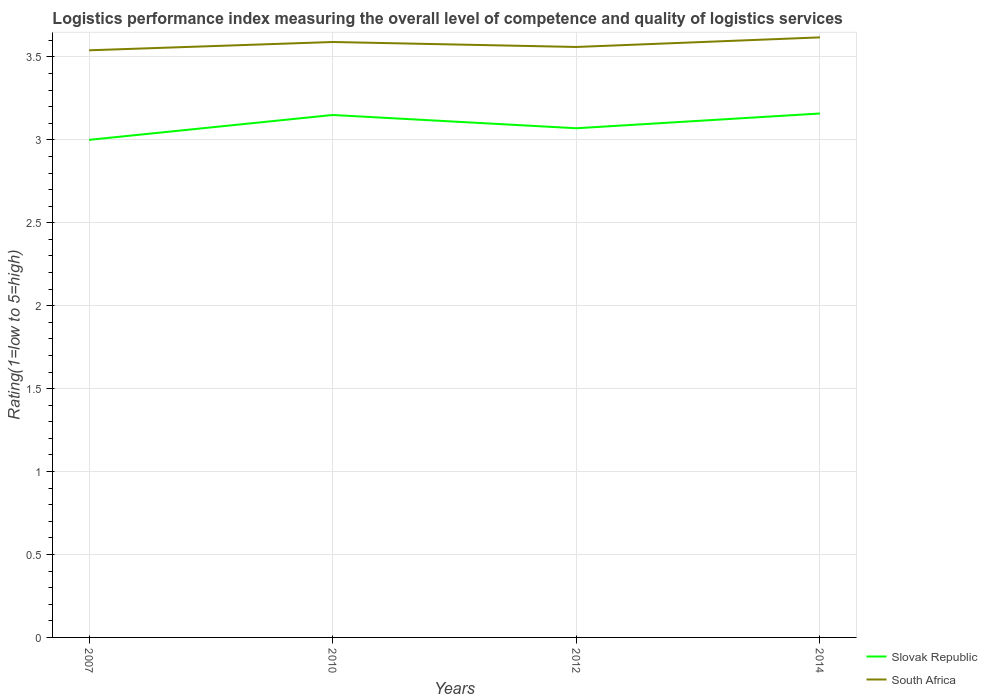How many different coloured lines are there?
Offer a terse response. 2. Does the line corresponding to South Africa intersect with the line corresponding to Slovak Republic?
Ensure brevity in your answer.  No. Is the number of lines equal to the number of legend labels?
Give a very brief answer. Yes. Across all years, what is the maximum Logistic performance index in Slovak Republic?
Give a very brief answer. 3. What is the total Logistic performance index in South Africa in the graph?
Your answer should be compact. -0.05. What is the difference between the highest and the second highest Logistic performance index in South Africa?
Provide a succinct answer. 0.08. What is the difference between the highest and the lowest Logistic performance index in South Africa?
Offer a very short reply. 2. Is the Logistic performance index in Slovak Republic strictly greater than the Logistic performance index in South Africa over the years?
Keep it short and to the point. Yes. How many lines are there?
Keep it short and to the point. 2. What is the difference between two consecutive major ticks on the Y-axis?
Ensure brevity in your answer.  0.5. Are the values on the major ticks of Y-axis written in scientific E-notation?
Provide a succinct answer. No. Does the graph contain grids?
Your answer should be very brief. Yes. Where does the legend appear in the graph?
Your answer should be compact. Bottom right. How many legend labels are there?
Ensure brevity in your answer.  2. How are the legend labels stacked?
Keep it short and to the point. Vertical. What is the title of the graph?
Offer a very short reply. Logistics performance index measuring the overall level of competence and quality of logistics services. What is the label or title of the X-axis?
Your answer should be very brief. Years. What is the label or title of the Y-axis?
Keep it short and to the point. Rating(1=low to 5=high). What is the Rating(1=low to 5=high) in Slovak Republic in 2007?
Keep it short and to the point. 3. What is the Rating(1=low to 5=high) in South Africa in 2007?
Give a very brief answer. 3.54. What is the Rating(1=low to 5=high) in Slovak Republic in 2010?
Make the answer very short. 3.15. What is the Rating(1=low to 5=high) in South Africa in 2010?
Provide a short and direct response. 3.59. What is the Rating(1=low to 5=high) in Slovak Republic in 2012?
Make the answer very short. 3.07. What is the Rating(1=low to 5=high) of South Africa in 2012?
Your response must be concise. 3.56. What is the Rating(1=low to 5=high) in Slovak Republic in 2014?
Provide a short and direct response. 3.16. What is the Rating(1=low to 5=high) in South Africa in 2014?
Provide a succinct answer. 3.62. Across all years, what is the maximum Rating(1=low to 5=high) in Slovak Republic?
Keep it short and to the point. 3.16. Across all years, what is the maximum Rating(1=low to 5=high) of South Africa?
Your response must be concise. 3.62. Across all years, what is the minimum Rating(1=low to 5=high) of South Africa?
Provide a succinct answer. 3.54. What is the total Rating(1=low to 5=high) in Slovak Republic in the graph?
Your response must be concise. 12.38. What is the total Rating(1=low to 5=high) of South Africa in the graph?
Your answer should be very brief. 14.31. What is the difference between the Rating(1=low to 5=high) in South Africa in 2007 and that in 2010?
Give a very brief answer. -0.05. What is the difference between the Rating(1=low to 5=high) of Slovak Republic in 2007 and that in 2012?
Give a very brief answer. -0.07. What is the difference between the Rating(1=low to 5=high) of South Africa in 2007 and that in 2012?
Offer a terse response. -0.02. What is the difference between the Rating(1=low to 5=high) of Slovak Republic in 2007 and that in 2014?
Your answer should be very brief. -0.16. What is the difference between the Rating(1=low to 5=high) in South Africa in 2007 and that in 2014?
Your response must be concise. -0.08. What is the difference between the Rating(1=low to 5=high) of South Africa in 2010 and that in 2012?
Your response must be concise. 0.03. What is the difference between the Rating(1=low to 5=high) in Slovak Republic in 2010 and that in 2014?
Offer a very short reply. -0.01. What is the difference between the Rating(1=low to 5=high) in South Africa in 2010 and that in 2014?
Your response must be concise. -0.03. What is the difference between the Rating(1=low to 5=high) in Slovak Republic in 2012 and that in 2014?
Provide a succinct answer. -0.09. What is the difference between the Rating(1=low to 5=high) in South Africa in 2012 and that in 2014?
Provide a succinct answer. -0.06. What is the difference between the Rating(1=low to 5=high) in Slovak Republic in 2007 and the Rating(1=low to 5=high) in South Africa in 2010?
Your answer should be compact. -0.59. What is the difference between the Rating(1=low to 5=high) in Slovak Republic in 2007 and the Rating(1=low to 5=high) in South Africa in 2012?
Make the answer very short. -0.56. What is the difference between the Rating(1=low to 5=high) in Slovak Republic in 2007 and the Rating(1=low to 5=high) in South Africa in 2014?
Your answer should be compact. -0.62. What is the difference between the Rating(1=low to 5=high) in Slovak Republic in 2010 and the Rating(1=low to 5=high) in South Africa in 2012?
Provide a short and direct response. -0.41. What is the difference between the Rating(1=low to 5=high) in Slovak Republic in 2010 and the Rating(1=low to 5=high) in South Africa in 2014?
Give a very brief answer. -0.47. What is the difference between the Rating(1=low to 5=high) in Slovak Republic in 2012 and the Rating(1=low to 5=high) in South Africa in 2014?
Provide a short and direct response. -0.55. What is the average Rating(1=low to 5=high) of Slovak Republic per year?
Your answer should be compact. 3.09. What is the average Rating(1=low to 5=high) of South Africa per year?
Your answer should be very brief. 3.58. In the year 2007, what is the difference between the Rating(1=low to 5=high) of Slovak Republic and Rating(1=low to 5=high) of South Africa?
Keep it short and to the point. -0.54. In the year 2010, what is the difference between the Rating(1=low to 5=high) in Slovak Republic and Rating(1=low to 5=high) in South Africa?
Make the answer very short. -0.44. In the year 2012, what is the difference between the Rating(1=low to 5=high) of Slovak Republic and Rating(1=low to 5=high) of South Africa?
Your response must be concise. -0.49. In the year 2014, what is the difference between the Rating(1=low to 5=high) of Slovak Republic and Rating(1=low to 5=high) of South Africa?
Keep it short and to the point. -0.46. What is the ratio of the Rating(1=low to 5=high) of Slovak Republic in 2007 to that in 2010?
Ensure brevity in your answer.  0.95. What is the ratio of the Rating(1=low to 5=high) in South Africa in 2007 to that in 2010?
Keep it short and to the point. 0.99. What is the ratio of the Rating(1=low to 5=high) of Slovak Republic in 2007 to that in 2012?
Ensure brevity in your answer.  0.98. What is the ratio of the Rating(1=low to 5=high) of South Africa in 2007 to that in 2012?
Provide a succinct answer. 0.99. What is the ratio of the Rating(1=low to 5=high) of Slovak Republic in 2007 to that in 2014?
Your answer should be compact. 0.95. What is the ratio of the Rating(1=low to 5=high) of South Africa in 2007 to that in 2014?
Make the answer very short. 0.98. What is the ratio of the Rating(1=low to 5=high) in Slovak Republic in 2010 to that in 2012?
Your response must be concise. 1.03. What is the ratio of the Rating(1=low to 5=high) of South Africa in 2010 to that in 2012?
Provide a succinct answer. 1.01. What is the ratio of the Rating(1=low to 5=high) of Slovak Republic in 2010 to that in 2014?
Ensure brevity in your answer.  1. What is the ratio of the Rating(1=low to 5=high) of Slovak Republic in 2012 to that in 2014?
Offer a terse response. 0.97. What is the ratio of the Rating(1=low to 5=high) in South Africa in 2012 to that in 2014?
Offer a very short reply. 0.98. What is the difference between the highest and the second highest Rating(1=low to 5=high) in Slovak Republic?
Offer a terse response. 0.01. What is the difference between the highest and the second highest Rating(1=low to 5=high) of South Africa?
Your answer should be very brief. 0.03. What is the difference between the highest and the lowest Rating(1=low to 5=high) of Slovak Republic?
Give a very brief answer. 0.16. What is the difference between the highest and the lowest Rating(1=low to 5=high) in South Africa?
Provide a succinct answer. 0.08. 